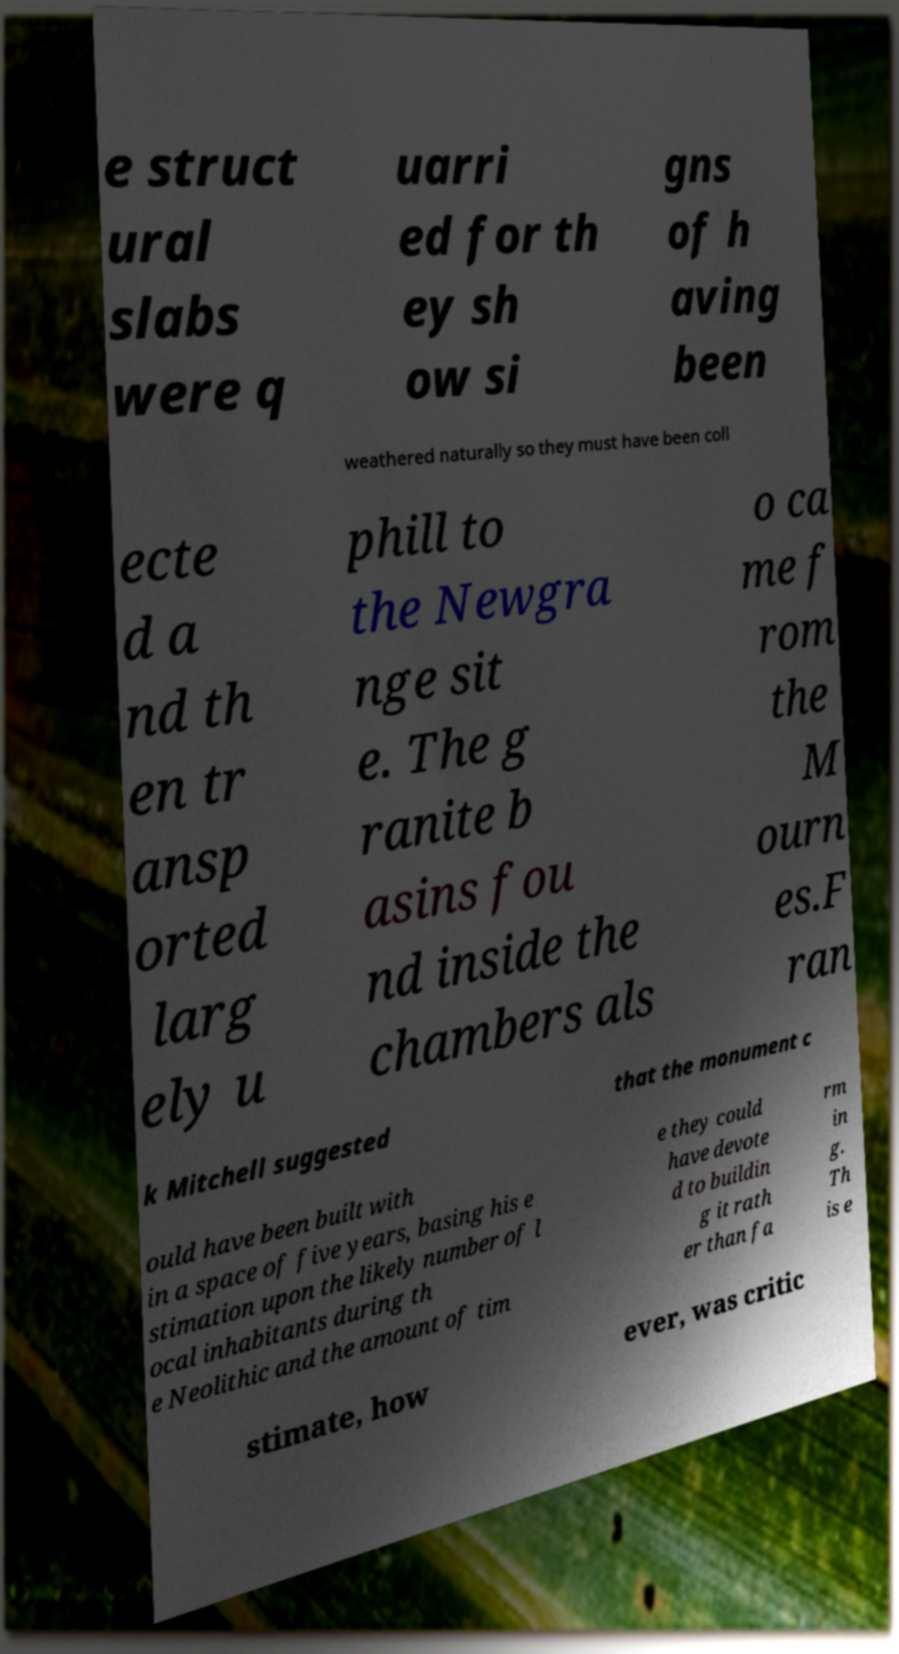Can you accurately transcribe the text from the provided image for me? e struct ural slabs were q uarri ed for th ey sh ow si gns of h aving been weathered naturally so they must have been coll ecte d a nd th en tr ansp orted larg ely u phill to the Newgra nge sit e. The g ranite b asins fou nd inside the chambers als o ca me f rom the M ourn es.F ran k Mitchell suggested that the monument c ould have been built with in a space of five years, basing his e stimation upon the likely number of l ocal inhabitants during th e Neolithic and the amount of tim e they could have devote d to buildin g it rath er than fa rm in g. Th is e stimate, how ever, was critic 